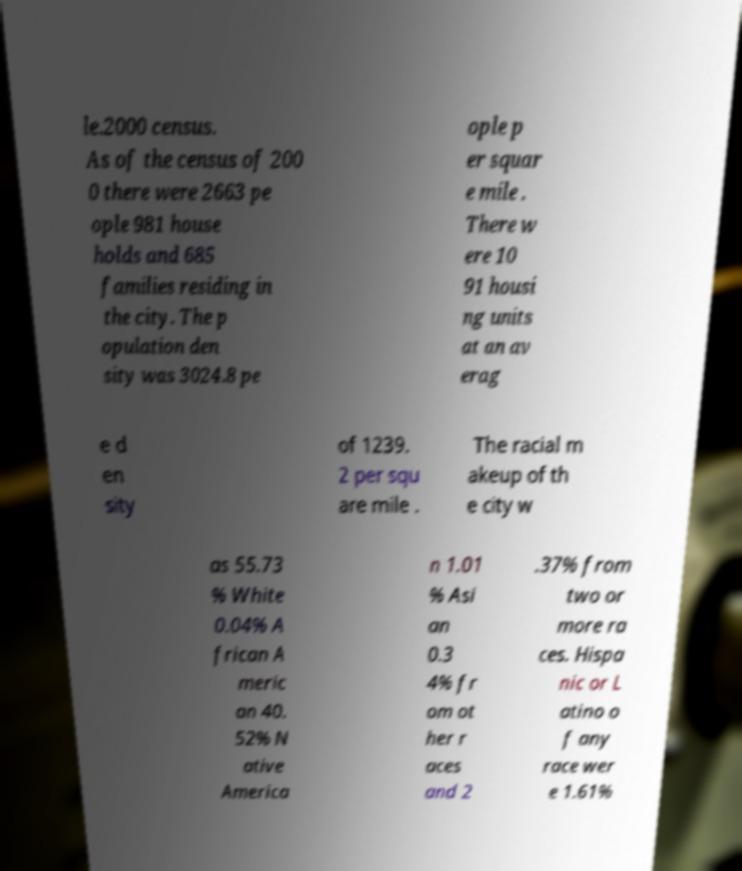Please identify and transcribe the text found in this image. le.2000 census. As of the census of 200 0 there were 2663 pe ople 981 house holds and 685 families residing in the city. The p opulation den sity was 3024.8 pe ople p er squar e mile . There w ere 10 91 housi ng units at an av erag e d en sity of 1239. 2 per squ are mile . The racial m akeup of th e city w as 55.73 % White 0.04% A frican A meric an 40. 52% N ative America n 1.01 % Asi an 0.3 4% fr om ot her r aces and 2 .37% from two or more ra ces. Hispa nic or L atino o f any race wer e 1.61% 